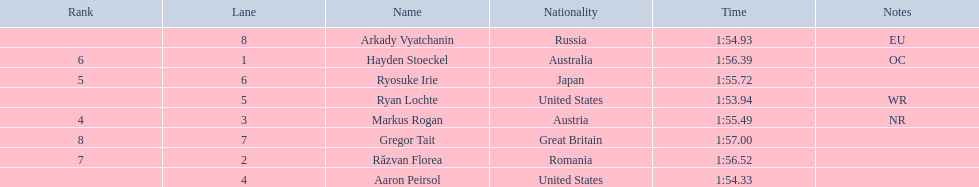Who are the swimmers? Ryan Lochte, Aaron Peirsol, Arkady Vyatchanin, Markus Rogan, Ryosuke Irie, Hayden Stoeckel, Răzvan Florea, Gregor Tait. What is ryosuke irie's time? 1:55.72. 